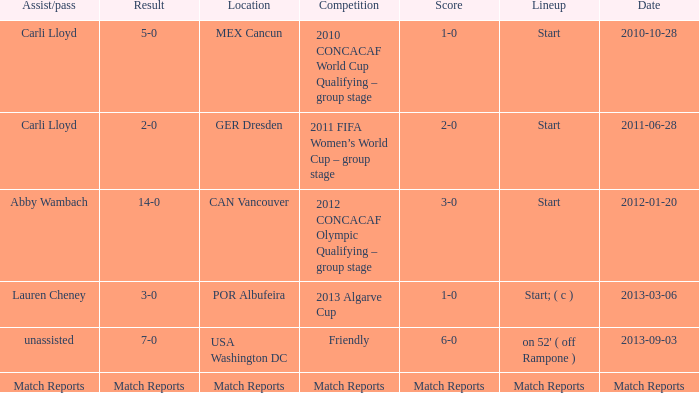Where has a score of match reports? Match Reports. 